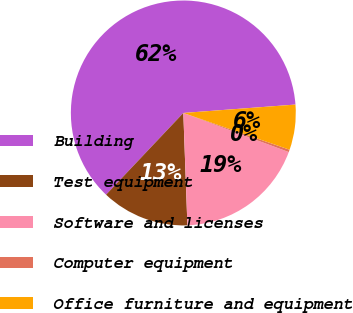Convert chart. <chart><loc_0><loc_0><loc_500><loc_500><pie_chart><fcel>Building<fcel>Test equipment<fcel>Software and licenses<fcel>Computer equipment<fcel>Office furniture and equipment<nl><fcel>61.75%<fcel>12.63%<fcel>18.77%<fcel>0.35%<fcel>6.49%<nl></chart> 